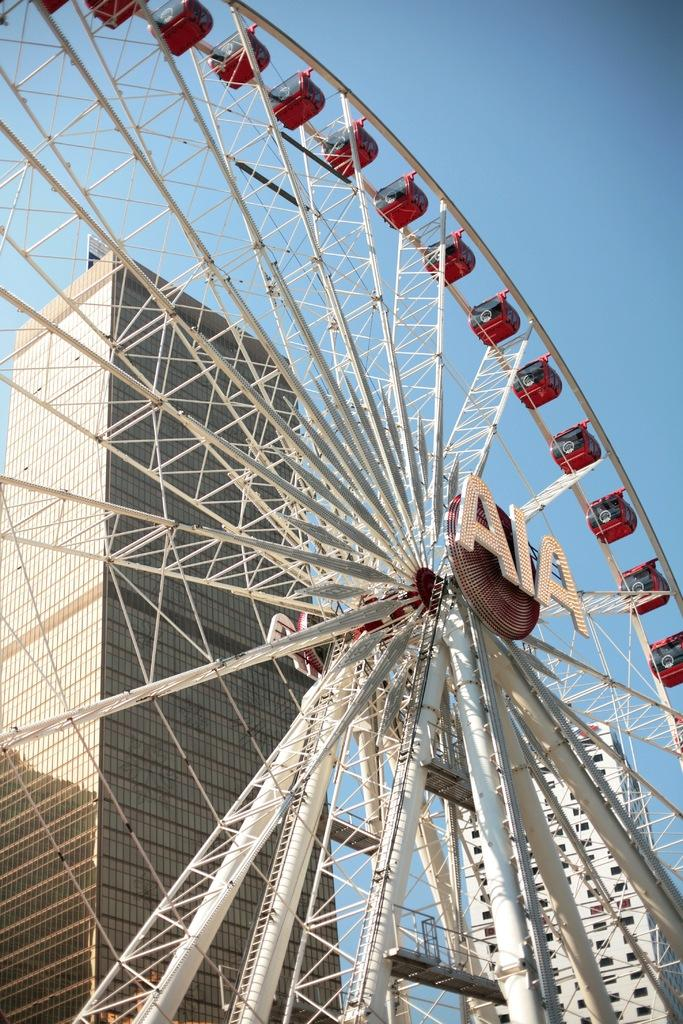What is the main subject of the image? The main subject of the image is a giant wheel. What can be seen in the background of the image? There is a building in the background of the image. What is visible at the top of the image? The sky is visible at the top of the image. What is present on the giant wheel? There is a hoarding in the middle of the giant wheel. How much profit does the butter-making machine generate in the image? There is no butter-making machine or mention of profit in the image. 